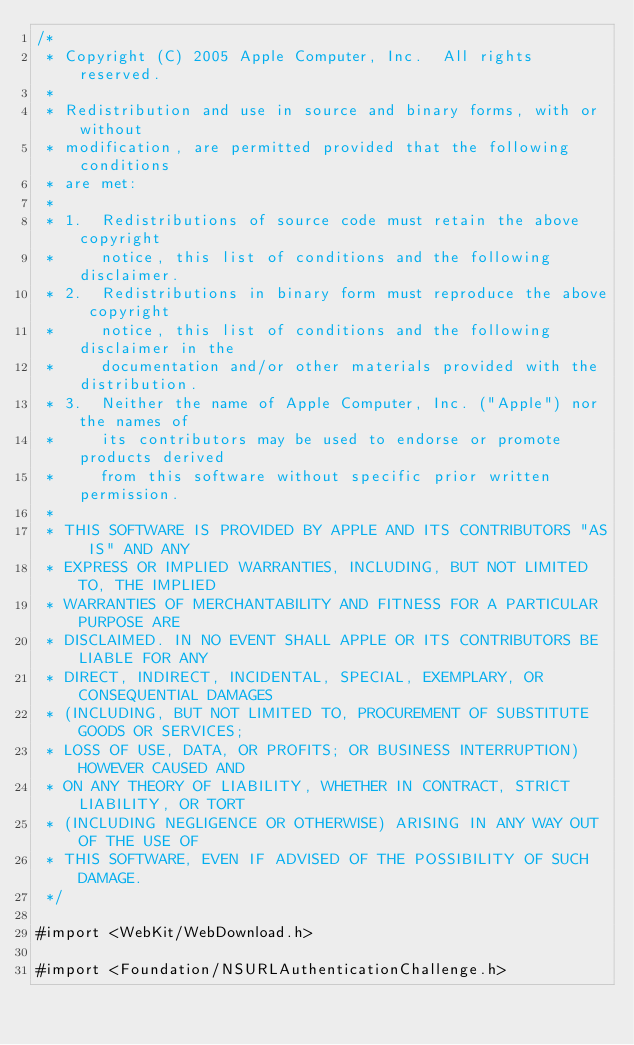<code> <loc_0><loc_0><loc_500><loc_500><_ObjectiveC_>/*
 * Copyright (C) 2005 Apple Computer, Inc.  All rights reserved.
 *
 * Redistribution and use in source and binary forms, with or without
 * modification, are permitted provided that the following conditions
 * are met:
 *
 * 1.  Redistributions of source code must retain the above copyright
 *     notice, this list of conditions and the following disclaimer. 
 * 2.  Redistributions in binary form must reproduce the above copyright
 *     notice, this list of conditions and the following disclaimer in the
 *     documentation and/or other materials provided with the distribution. 
 * 3.  Neither the name of Apple Computer, Inc. ("Apple") nor the names of
 *     its contributors may be used to endorse or promote products derived
 *     from this software without specific prior written permission. 
 *
 * THIS SOFTWARE IS PROVIDED BY APPLE AND ITS CONTRIBUTORS "AS IS" AND ANY
 * EXPRESS OR IMPLIED WARRANTIES, INCLUDING, BUT NOT LIMITED TO, THE IMPLIED
 * WARRANTIES OF MERCHANTABILITY AND FITNESS FOR A PARTICULAR PURPOSE ARE
 * DISCLAIMED. IN NO EVENT SHALL APPLE OR ITS CONTRIBUTORS BE LIABLE FOR ANY
 * DIRECT, INDIRECT, INCIDENTAL, SPECIAL, EXEMPLARY, OR CONSEQUENTIAL DAMAGES
 * (INCLUDING, BUT NOT LIMITED TO, PROCUREMENT OF SUBSTITUTE GOODS OR SERVICES;
 * LOSS OF USE, DATA, OR PROFITS; OR BUSINESS INTERRUPTION) HOWEVER CAUSED AND
 * ON ANY THEORY OF LIABILITY, WHETHER IN CONTRACT, STRICT LIABILITY, OR TORT
 * (INCLUDING NEGLIGENCE OR OTHERWISE) ARISING IN ANY WAY OUT OF THE USE OF
 * THIS SOFTWARE, EVEN IF ADVISED OF THE POSSIBILITY OF SUCH DAMAGE.
 */

#import <WebKit/WebDownload.h>

#import <Foundation/NSURLAuthenticationChallenge.h></code> 